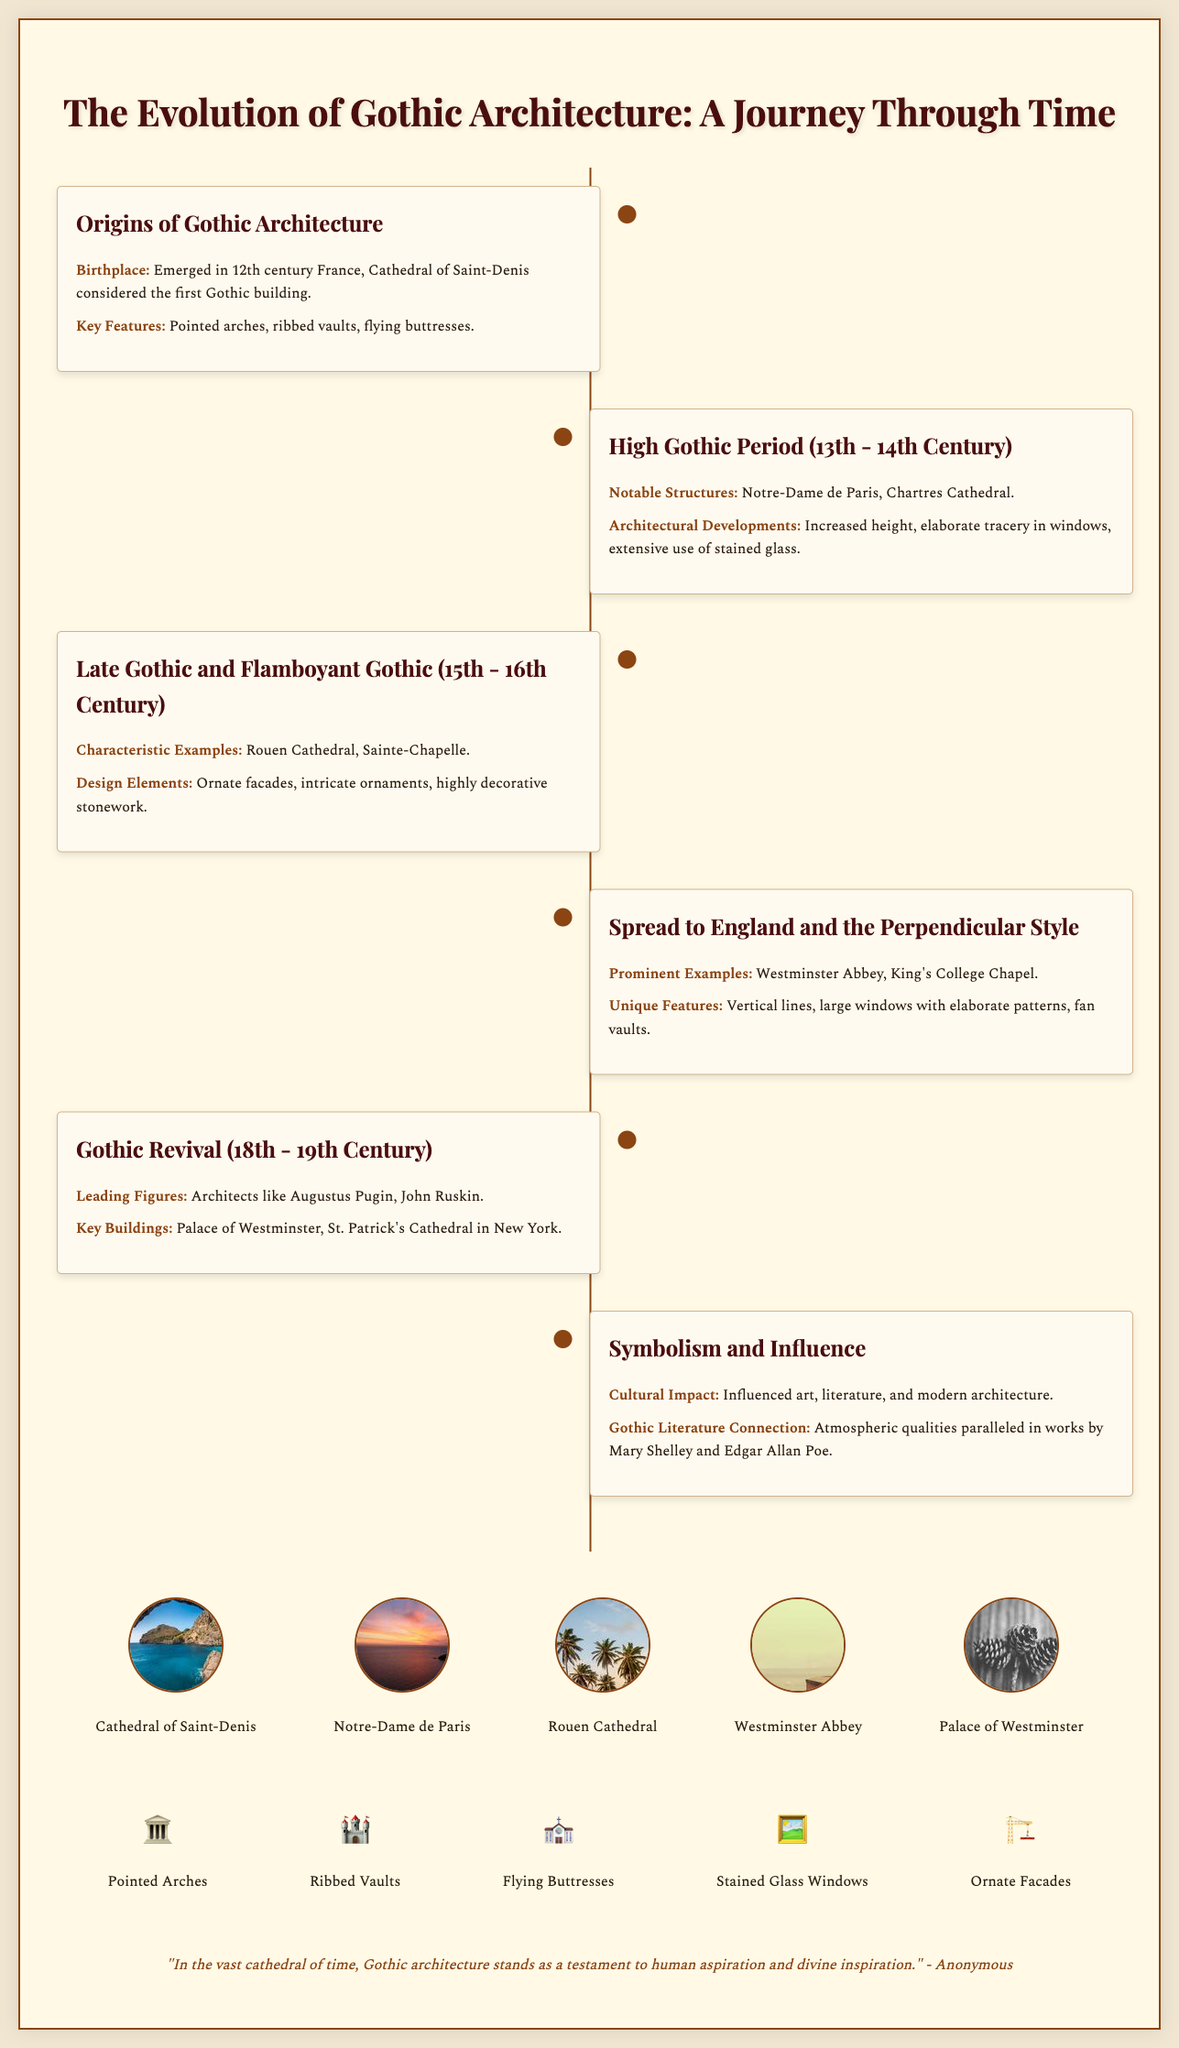What is the birthplace of Gothic architecture? The document states that Gothic architecture emerged in 12th century France, specifically noting the Cathedral of Saint-Denis as the first Gothic building.
Answer: 12th century France Which cathedral is noted for the High Gothic period? The document lists Notre-Dame de Paris and Chartres Cathedral as notable structures during this period.
Answer: Notre-Dame de Paris What architectural feature is associated with the Late Gothic period? The document mentions ornate facades, intricate ornaments, and highly decorative stonework as key design elements of this period.
Answer: Ornate facades What is an example of a prominent Gothic structure in England? The document points out Westminster Abbey as a notable Gothic structure in England.
Answer: Westminster Abbey Who were the leading figures in the Gothic Revival? The document indicates Augustus Pugin and John Ruskin as leading figures during the Gothic Revival.
Answer: Augustus Pugin, John Ruskin In which century did the Gothic Revival occur? The document states that the Gothic Revival took place in the 18th to 19th centuries.
Answer: 18th - 19th Century What cultural impact did Gothic architecture have? The document notes that Gothic architecture influenced art, literature, and modern architecture.
Answer: Influenced art, literature, and modern architecture Which Gothic structure is known for its flying buttresses? The document lists flying buttresses as a key feature of Gothic architecture without specifying a particular structure.
Answer: Flying buttresses What is one characteristic of the Flamboyant Gothic style? The document describes Flamboyant Gothic as featuring intricate stonework and ornate design elements.
Answer: Intricate stonework 